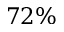Convert formula to latex. <formula><loc_0><loc_0><loc_500><loc_500>7 2 \%</formula> 